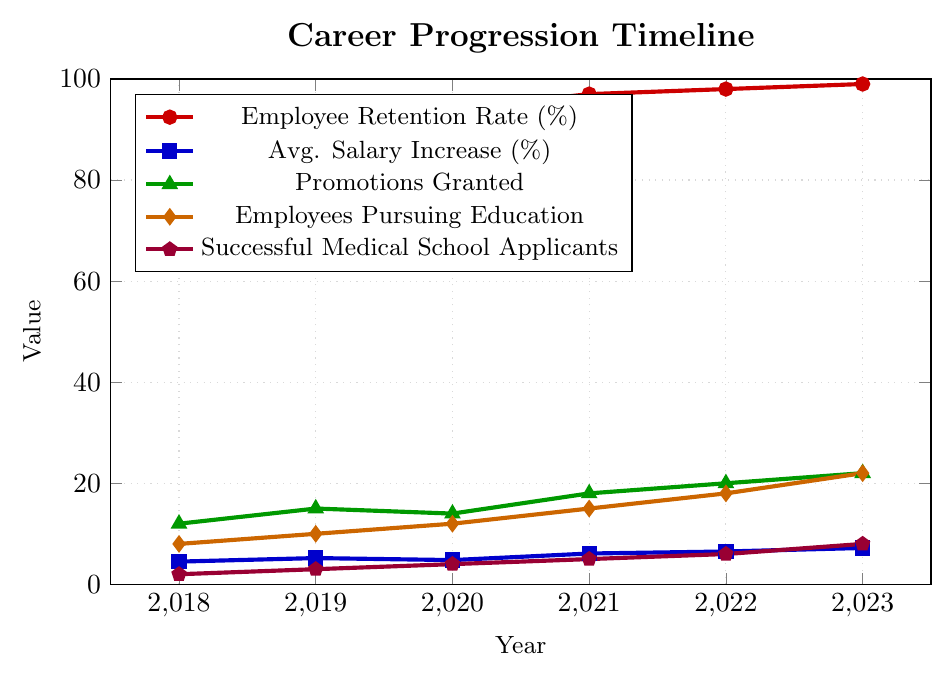How does the Employee Retention Rate change from 2018 to 2023? The chart shows the Employee Retention Rate as a line in red with markers. By observing the left y-axis, the Retention Rate increases from 92% in 2018 to 99% in 2023.
Answer: It increases from 92% to 99% What is the difference between the Avg. Salary Increase % in 2023 and 2018? The chart shows the Avg. Salary Increase % as a line plot in blue. In 2018, it is 4.5%, and in 2023, it is 7.2%. The difference is calculated as 7.2% - 4.5% = 2.7%.
Answer: 2.7% Which year had the most Promotions Granted, and how many were granted that year? The chart shows Promotions Granted as a green line. The highest point is in 2023 with 22 promotions granted.
Answer: 2023, 22 promotions Compare the number of Employees Pursuing Education in 2018 and 2023. The chart uses an orange line to represent Employees Pursuing Education. In 2018, there were 8 employees, and in 2023, there are 22.
Answer: 8 in 2018, 22 in 2023 What is the trend in Successful Medical School Applicants from 2018 to 2023? The chart uses a purple line to denote Successful Medical School Applicants. The number increases steadily from 2 in 2018 to 8 in 2023.
Answer: Increasing By how much did the Employee Retention Rate increase from 2019 to 2020? The chart shows the Employee Retention Rate values with red markers. In 2019, it is 95%, and in 2020, it is 94%, so it actually decreased by 1%.
Answer: Decrease by 1% What is the sum of Promotions Granted in the years 2019, 2020, and 2021? The green line shows Promotions Granted: 15 in 2019, 14 in 2020, and 18 in 2021. Summing these values gives 15 + 14 + 18 = 47.
Answer: 47 Which metric shows the fastest growth rate from 2018 to 2023? By looking at all the lines, the Successful Medical School Applicants (purple line) increased from 2 to 8, which is a 4-fold increase, the fastest among all metrics.
Answer: Successful Medical School Applicants Compare the Avg. Salary Increase % trends in 2021 and 2023. Which is higher and by how much? The Avg. Salary Increase % (blue line) in 2021 is 6.1%, and in 2023 is 7.2%. The difference is 7.2% - 6.1% = 1.1%.
Answer: 2023, by 1.1% How many years saw a consecutive increase in the number of Employees Pursuing Education? The orange line shows consecutive increases in Employees Pursuing Education from 2018 (8) to 2023 (22). Every year in this period saw an increase, making 5 consecutive years.
Answer: 5 years 